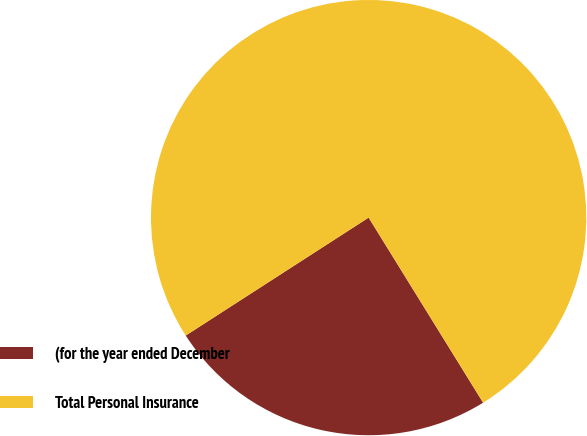<chart> <loc_0><loc_0><loc_500><loc_500><pie_chart><fcel>(for the year ended December<fcel>Total Personal Insurance<nl><fcel>24.7%<fcel>75.3%<nl></chart> 